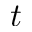<formula> <loc_0><loc_0><loc_500><loc_500>t</formula> 